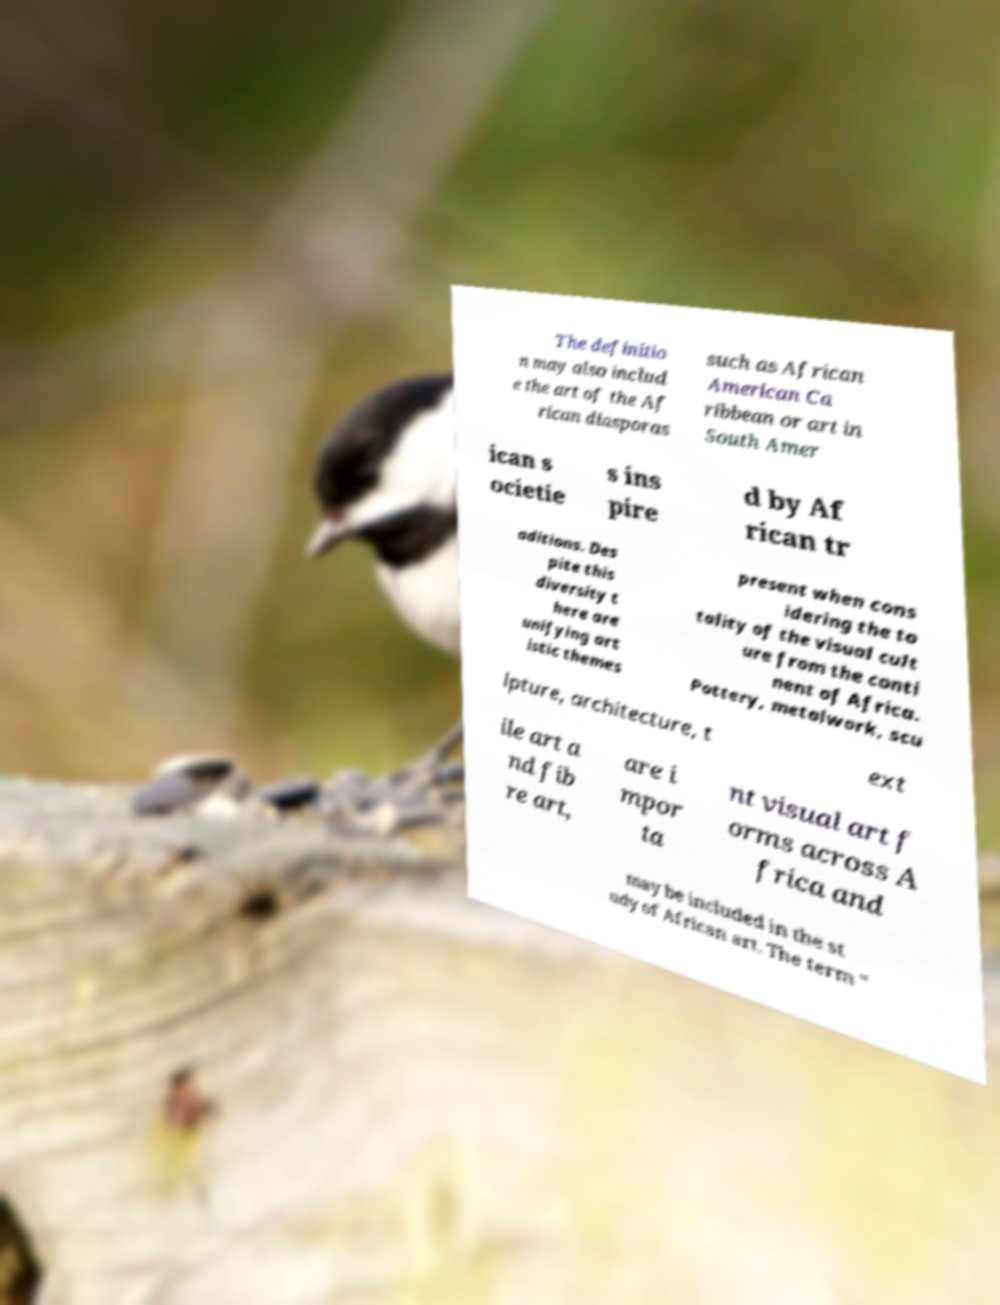There's text embedded in this image that I need extracted. Can you transcribe it verbatim? The definitio n may also includ e the art of the Af rican diasporas such as African American Ca ribbean or art in South Amer ican s ocietie s ins pire d by Af rican tr aditions. Des pite this diversity t here are unifying art istic themes present when cons idering the to tality of the visual cult ure from the conti nent of Africa. Pottery, metalwork, scu lpture, architecture, t ext ile art a nd fib re art, are i mpor ta nt visual art f orms across A frica and may be included in the st udy of African art. The term " 